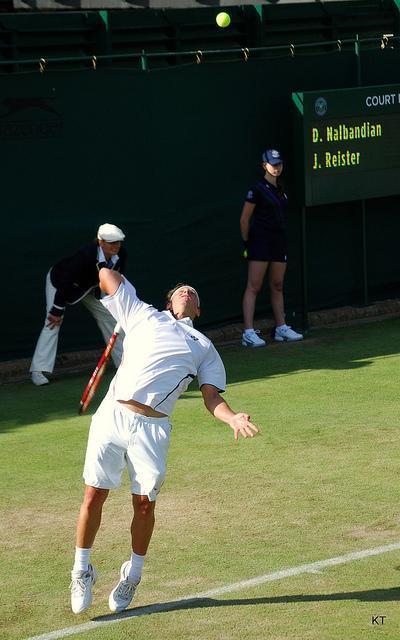How many people are in the picture?
Give a very brief answer. 3. How many bottles on the cutting board are uncorked?
Give a very brief answer. 0. 